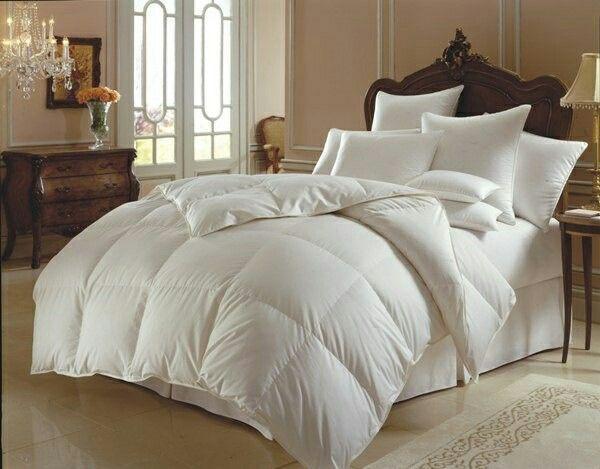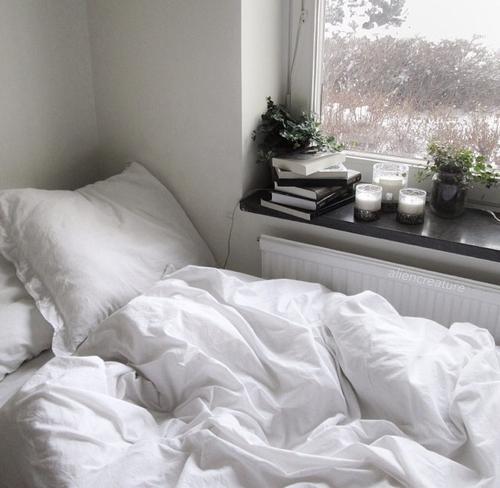The first image is the image on the left, the second image is the image on the right. Assess this claim about the two images: "There are flowers in a vase in one of the images.". Correct or not? Answer yes or no. Yes. 